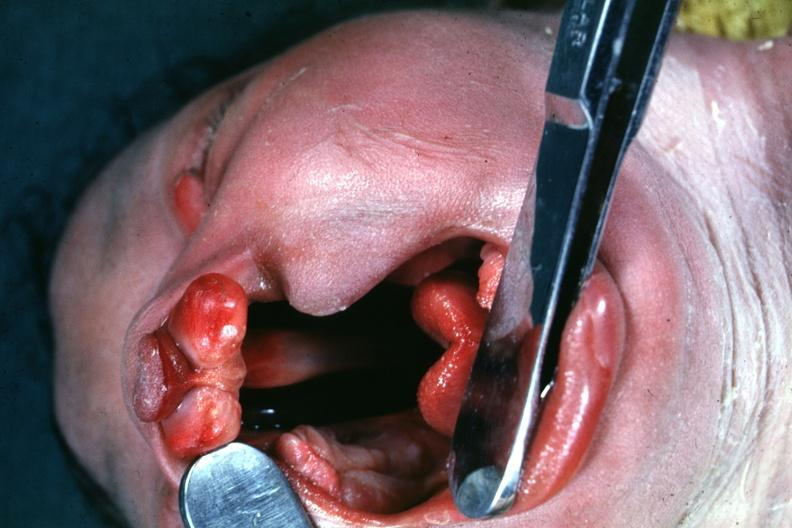what is present?
Answer the question using a single word or phrase. Bilateral cleft palate 